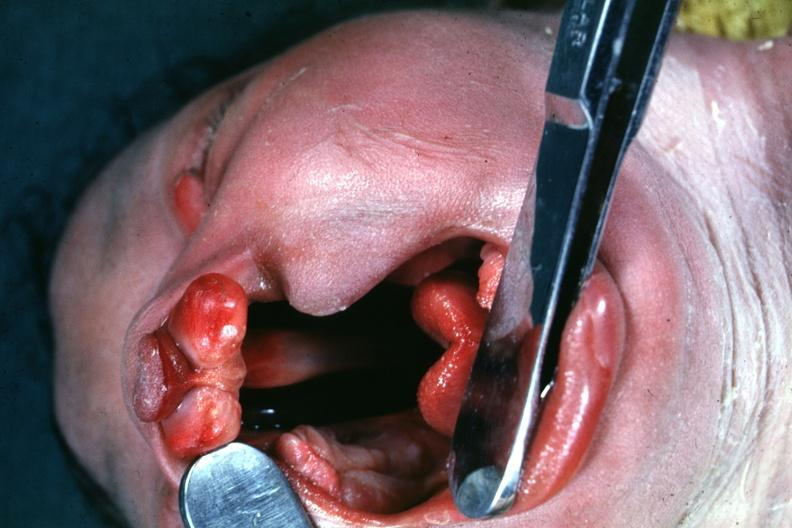what is present?
Answer the question using a single word or phrase. Bilateral cleft palate 